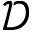Convert formula to latex. <formula><loc_0><loc_0><loc_500><loc_500>\mathcal { D }</formula> 